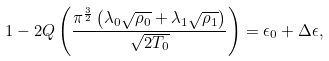Convert formula to latex. <formula><loc_0><loc_0><loc_500><loc_500>1 - 2 Q \left ( \frac { \pi ^ { \frac { 3 } { 2 } } \left ( \lambda _ { 0 } \sqrt { \rho _ { 0 } } + \lambda _ { 1 } \sqrt { \rho _ { 1 } } \right ) } { \sqrt { 2 T _ { 0 } } } \right ) = \epsilon _ { 0 } + \Delta \epsilon ,</formula> 